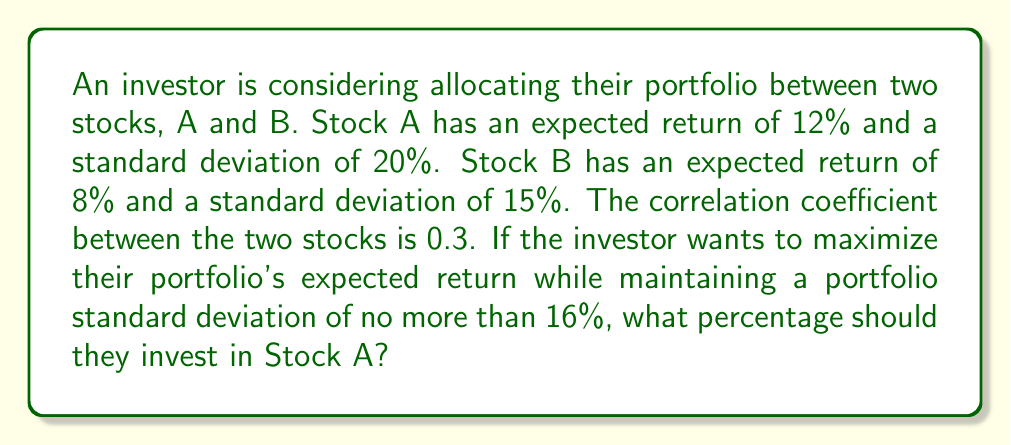Can you answer this question? Let's approach this step-by-step:

1) Let $w_A$ be the weight of Stock A in the portfolio. Then the weight of Stock B is $(1-w_A)$.

2) The expected return of the portfolio is:
   $$E(R_p) = w_A \cdot E(R_A) + (1-w_A) \cdot E(R_B)$$
   $$E(R_p) = 0.12w_A + 0.08(1-w_A) = 0.08 + 0.04w_A$$

3) The variance of the portfolio is given by:
   $$\sigma_p^2 = w_A^2\sigma_A^2 + (1-w_A)^2\sigma_B^2 + 2w_A(1-w_A)\rho_{AB}\sigma_A\sigma_B$$

   Where $\rho_{AB}$ is the correlation coefficient between A and B.

4) Substituting the values:
   $$\sigma_p^2 = w_A^2(0.2)^2 + (1-w_A)^2(0.15)^2 + 2w_A(1-w_A)(0.3)(0.2)(0.15)$$
   $$\sigma_p^2 = 0.04w_A^2 + 0.0225(1-2w_A+w_A^2) + 0.018w_A(1-w_A)$$
   $$\sigma_p^2 = 0.04w_A^2 + 0.0225 - 0.045w_A + 0.0225w_A^2 + 0.018w_A - 0.018w_A^2$$
   $$\sigma_p^2 = 0.0445w_A^2 - 0.027w_A + 0.0225$$

5) We want $\sigma_p \leq 0.16$, so:
   $$0.0445w_A^2 - 0.027w_A + 0.0225 \leq 0.16^2 = 0.0256$$
   $$0.0445w_A^2 - 0.027w_A - 0.0031 \leq 0$$

6) Solving this quadratic inequality:
   $$w_A = \frac{0.027 \pm \sqrt{0.027^2 + 4(0.0445)(0.0031)}}{2(0.0445)}$$
   $$w_A \approx 0.1359 \text{ or } w_A \approx 0.4707$$

7) Since we want to maximize return, we choose the larger value: $w_A \approx 0.4707$

8) Converting to a percentage: $0.4707 \times 100\% \approx 47.07\%$
Answer: 47.07% 